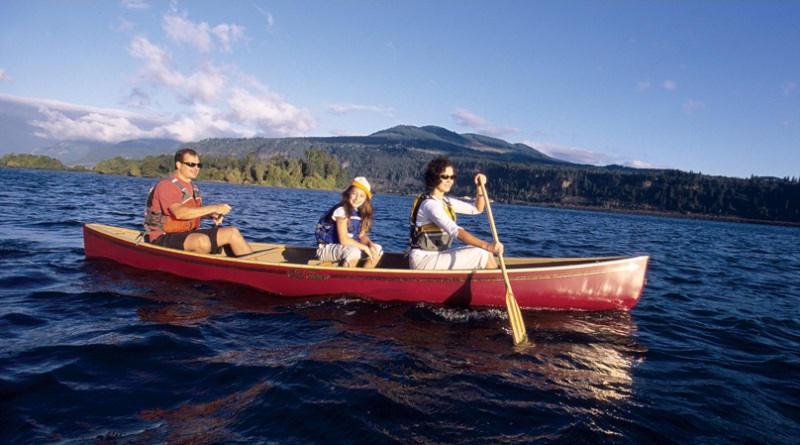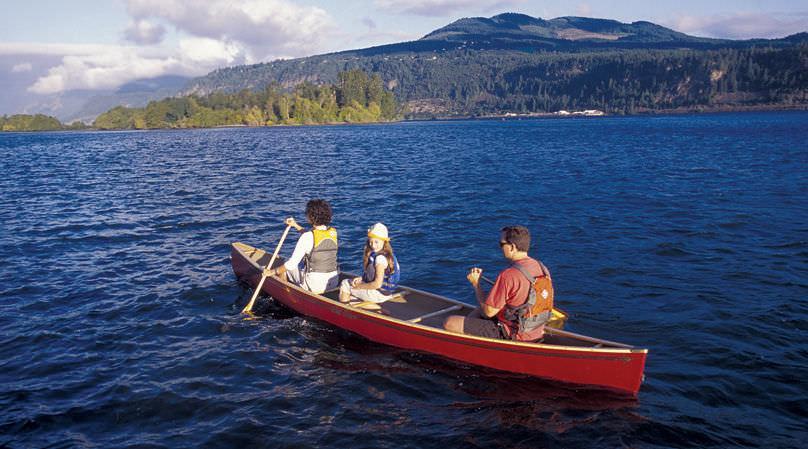The first image is the image on the left, the second image is the image on the right. For the images shown, is this caption "In one image, exactly two people, a man and a woman, are rowing a green canoe." true? Answer yes or no. No. The first image is the image on the left, the second image is the image on the right. Analyze the images presented: Is the assertion "An image shows one dark green canoe with two riders." valid? Answer yes or no. No. 